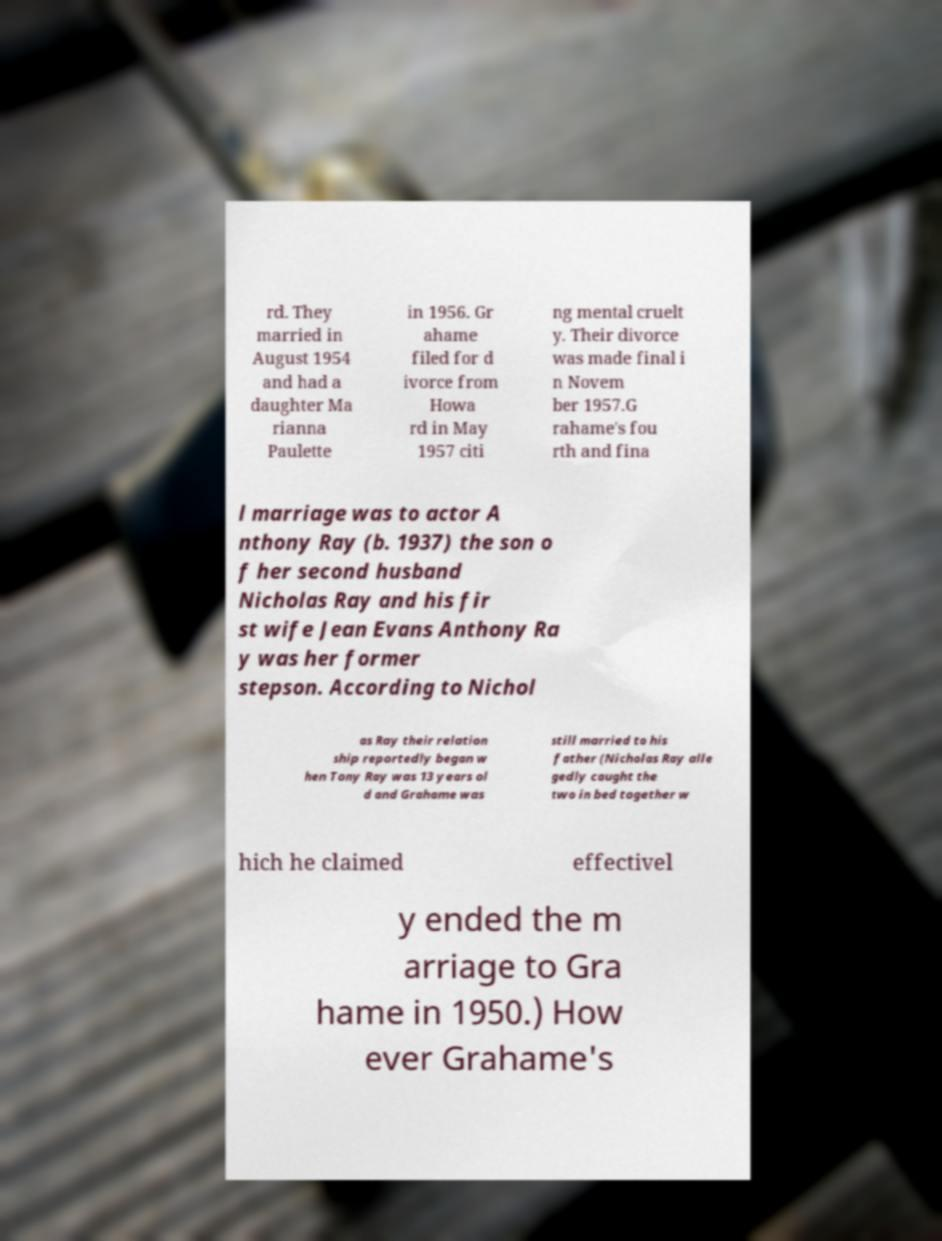Could you assist in decoding the text presented in this image and type it out clearly? rd. They married in August 1954 and had a daughter Ma rianna Paulette in 1956. Gr ahame filed for d ivorce from Howa rd in May 1957 citi ng mental cruelt y. Their divorce was made final i n Novem ber 1957.G rahame's fou rth and fina l marriage was to actor A nthony Ray (b. 1937) the son o f her second husband Nicholas Ray and his fir st wife Jean Evans Anthony Ra y was her former stepson. According to Nichol as Ray their relation ship reportedly began w hen Tony Ray was 13 years ol d and Grahame was still married to his father (Nicholas Ray alle gedly caught the two in bed together w hich he claimed effectivel y ended the m arriage to Gra hame in 1950.) How ever Grahame's 